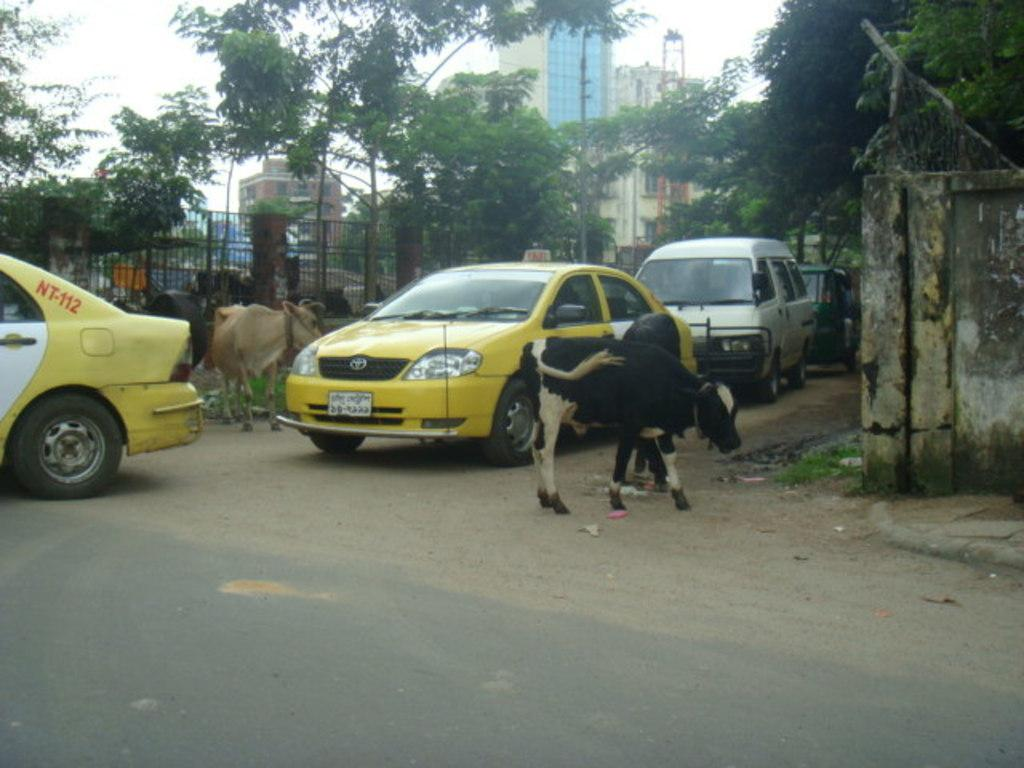<image>
Write a terse but informative summary of the picture. A cow wanders down a street with taxis in it, one has NT-112 on it. 